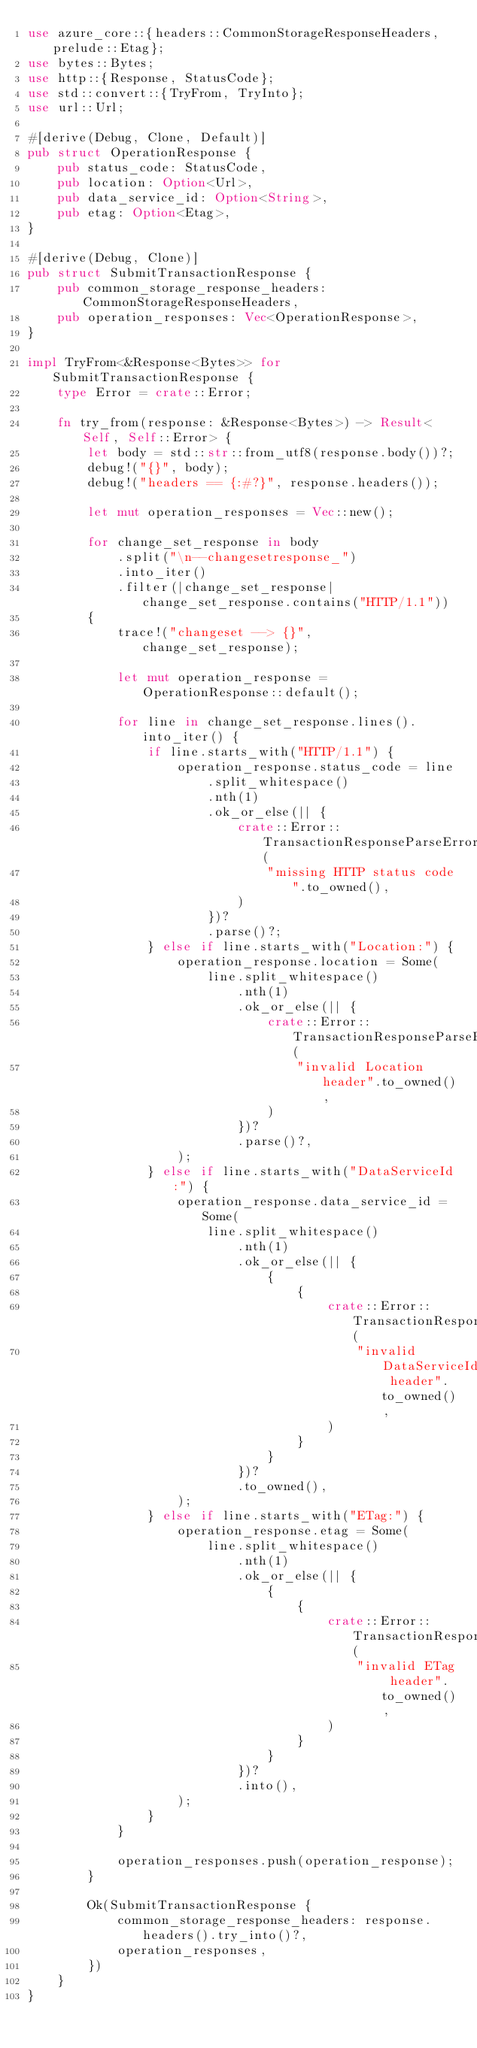Convert code to text. <code><loc_0><loc_0><loc_500><loc_500><_Rust_>use azure_core::{headers::CommonStorageResponseHeaders, prelude::Etag};
use bytes::Bytes;
use http::{Response, StatusCode};
use std::convert::{TryFrom, TryInto};
use url::Url;

#[derive(Debug, Clone, Default)]
pub struct OperationResponse {
    pub status_code: StatusCode,
    pub location: Option<Url>,
    pub data_service_id: Option<String>,
    pub etag: Option<Etag>,
}

#[derive(Debug, Clone)]
pub struct SubmitTransactionResponse {
    pub common_storage_response_headers: CommonStorageResponseHeaders,
    pub operation_responses: Vec<OperationResponse>,
}

impl TryFrom<&Response<Bytes>> for SubmitTransactionResponse {
    type Error = crate::Error;

    fn try_from(response: &Response<Bytes>) -> Result<Self, Self::Error> {
        let body = std::str::from_utf8(response.body())?;
        debug!("{}", body);
        debug!("headers == {:#?}", response.headers());

        let mut operation_responses = Vec::new();

        for change_set_response in body
            .split("\n--changesetresponse_")
            .into_iter()
            .filter(|change_set_response| change_set_response.contains("HTTP/1.1"))
        {
            trace!("changeset --> {}", change_set_response);

            let mut operation_response = OperationResponse::default();

            for line in change_set_response.lines().into_iter() {
                if line.starts_with("HTTP/1.1") {
                    operation_response.status_code = line
                        .split_whitespace()
                        .nth(1)
                        .ok_or_else(|| {
                            crate::Error::TransactionResponseParseError(
                                "missing HTTP status code".to_owned(),
                            )
                        })?
                        .parse()?;
                } else if line.starts_with("Location:") {
                    operation_response.location = Some(
                        line.split_whitespace()
                            .nth(1)
                            .ok_or_else(|| {
                                crate::Error::TransactionResponseParseError(
                                    "invalid Location header".to_owned(),
                                )
                            })?
                            .parse()?,
                    );
                } else if line.starts_with("DataServiceId:") {
                    operation_response.data_service_id = Some(
                        line.split_whitespace()
                            .nth(1)
                            .ok_or_else(|| {
                                {
                                    {
                                        crate::Error::TransactionResponseParseError(
                                            "invalid DataServiceId header".to_owned(),
                                        )
                                    }
                                }
                            })?
                            .to_owned(),
                    );
                } else if line.starts_with("ETag:") {
                    operation_response.etag = Some(
                        line.split_whitespace()
                            .nth(1)
                            .ok_or_else(|| {
                                {
                                    {
                                        crate::Error::TransactionResponseParseError(
                                            "invalid ETag header".to_owned(),
                                        )
                                    }
                                }
                            })?
                            .into(),
                    );
                }
            }

            operation_responses.push(operation_response);
        }

        Ok(SubmitTransactionResponse {
            common_storage_response_headers: response.headers().try_into()?,
            operation_responses,
        })
    }
}
</code> 